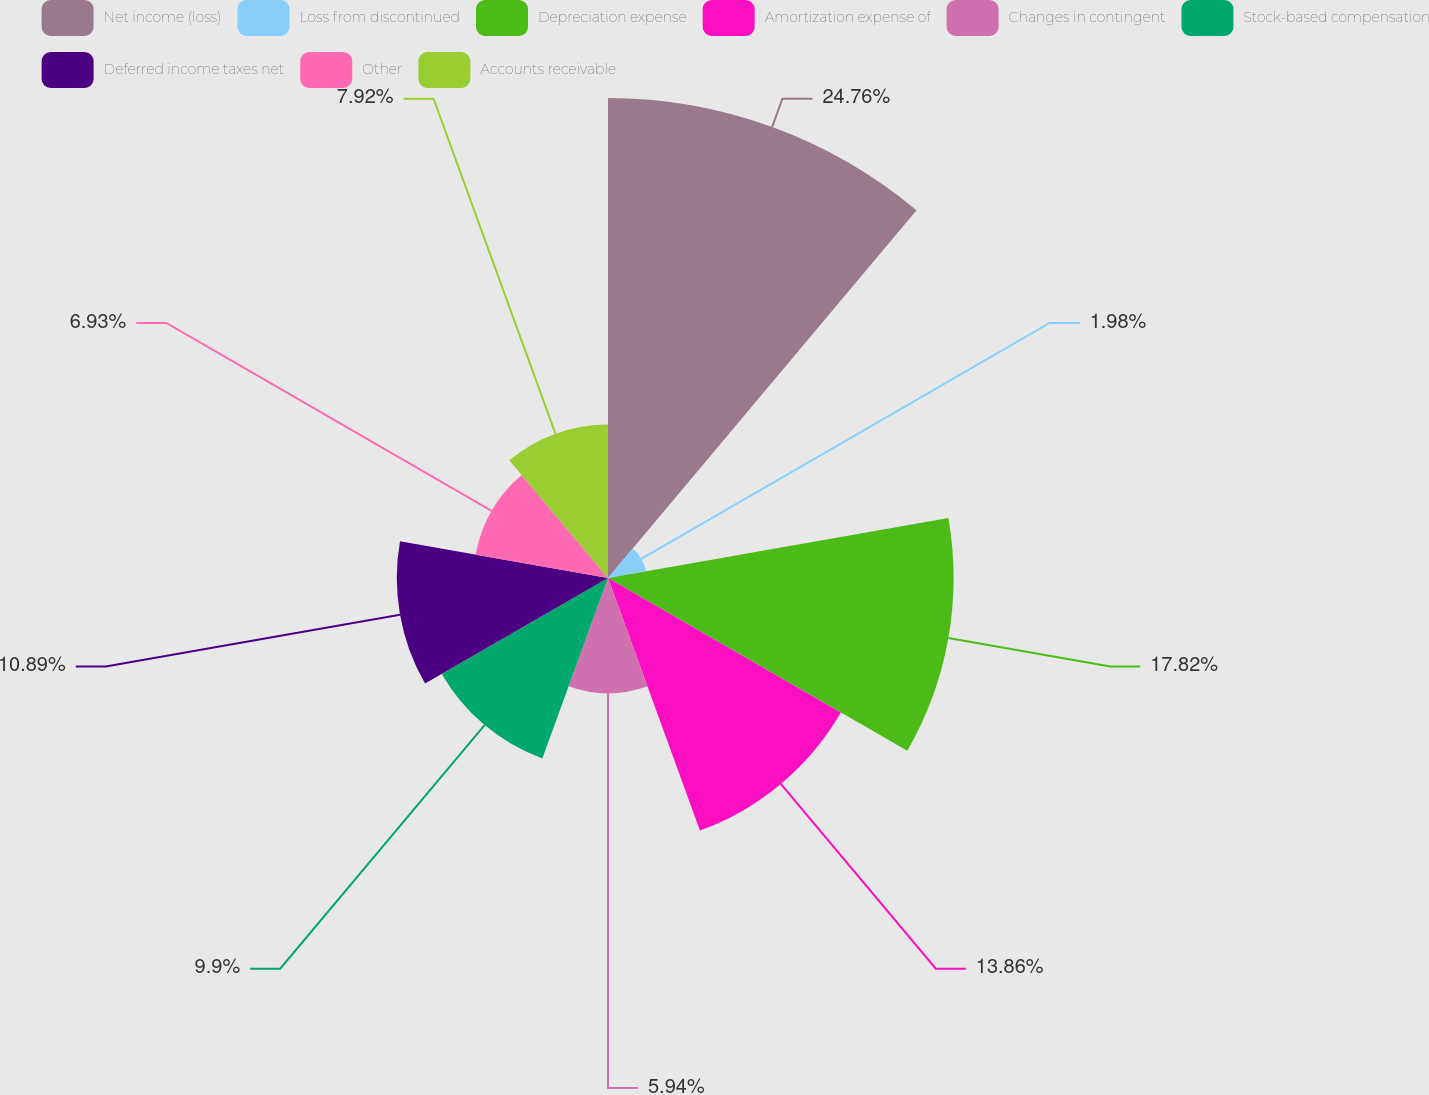Convert chart to OTSL. <chart><loc_0><loc_0><loc_500><loc_500><pie_chart><fcel>Net income (loss)<fcel>Loss from discontinued<fcel>Depreciation expense<fcel>Amortization expense of<fcel>Changes in contingent<fcel>Stock-based compensation<fcel>Deferred income taxes net<fcel>Other<fcel>Accounts receivable<nl><fcel>24.75%<fcel>1.98%<fcel>17.82%<fcel>13.86%<fcel>5.94%<fcel>9.9%<fcel>10.89%<fcel>6.93%<fcel>7.92%<nl></chart> 